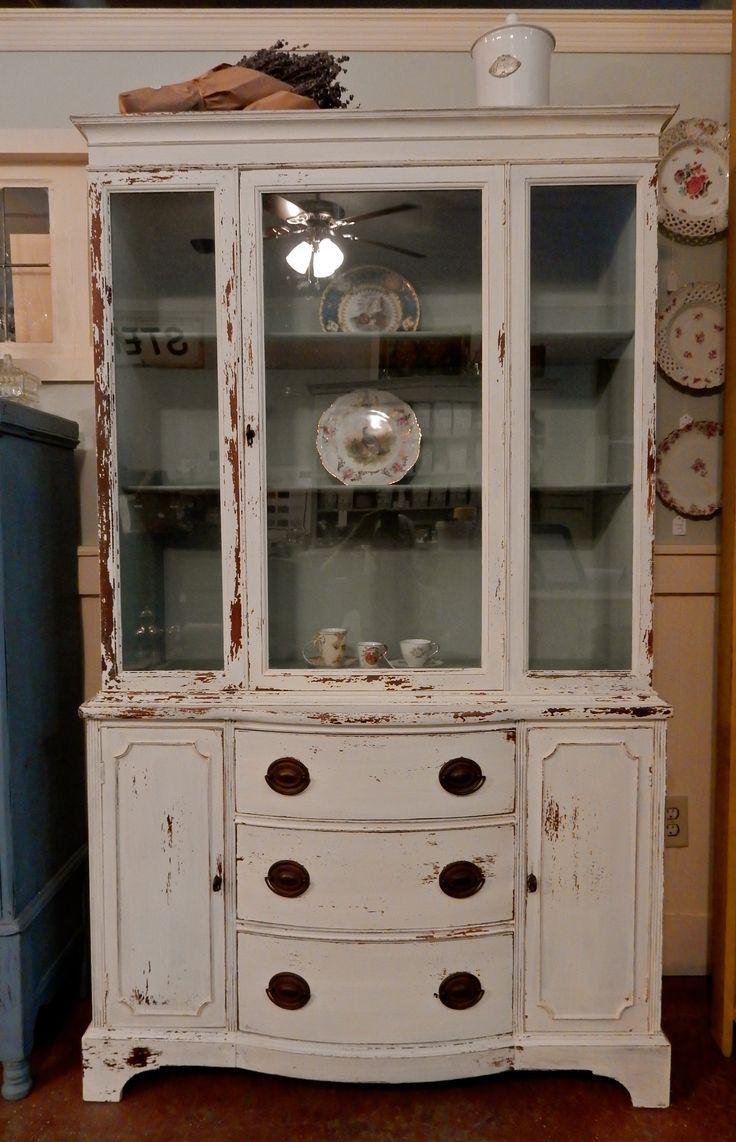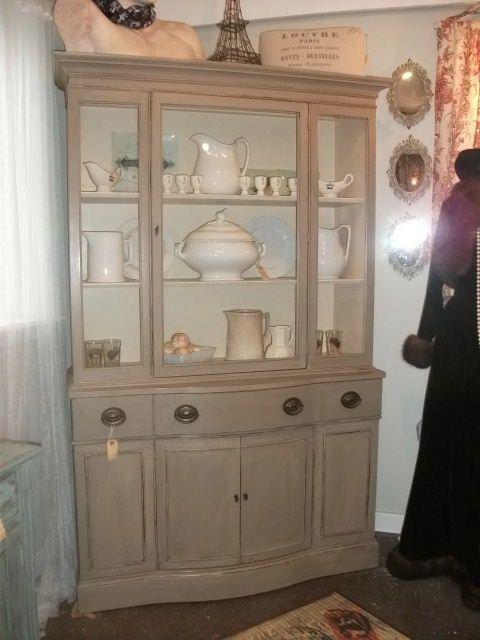The first image is the image on the left, the second image is the image on the right. Considering the images on both sides, is "A flat-topped cabinet includes bright yellow on at least some surface." valid? Answer yes or no. No. The first image is the image on the left, the second image is the image on the right. Analyze the images presented: Is the assertion "At least one white furniture contain dishes." valid? Answer yes or no. Yes. 